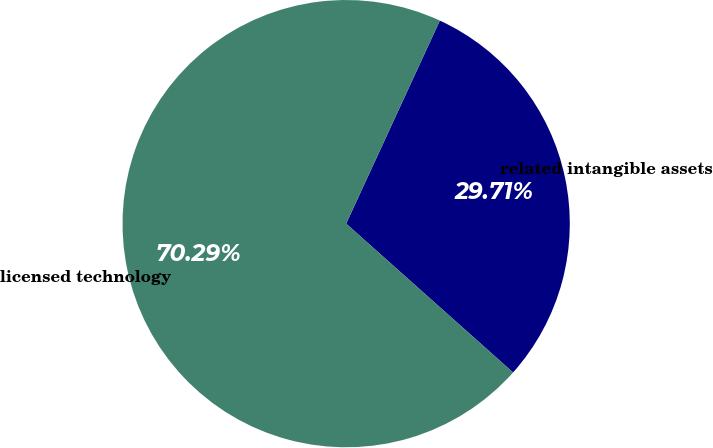Convert chart. <chart><loc_0><loc_0><loc_500><loc_500><pie_chart><fcel>related intangible assets<fcel>licensed technology<nl><fcel>29.71%<fcel>70.29%<nl></chart> 